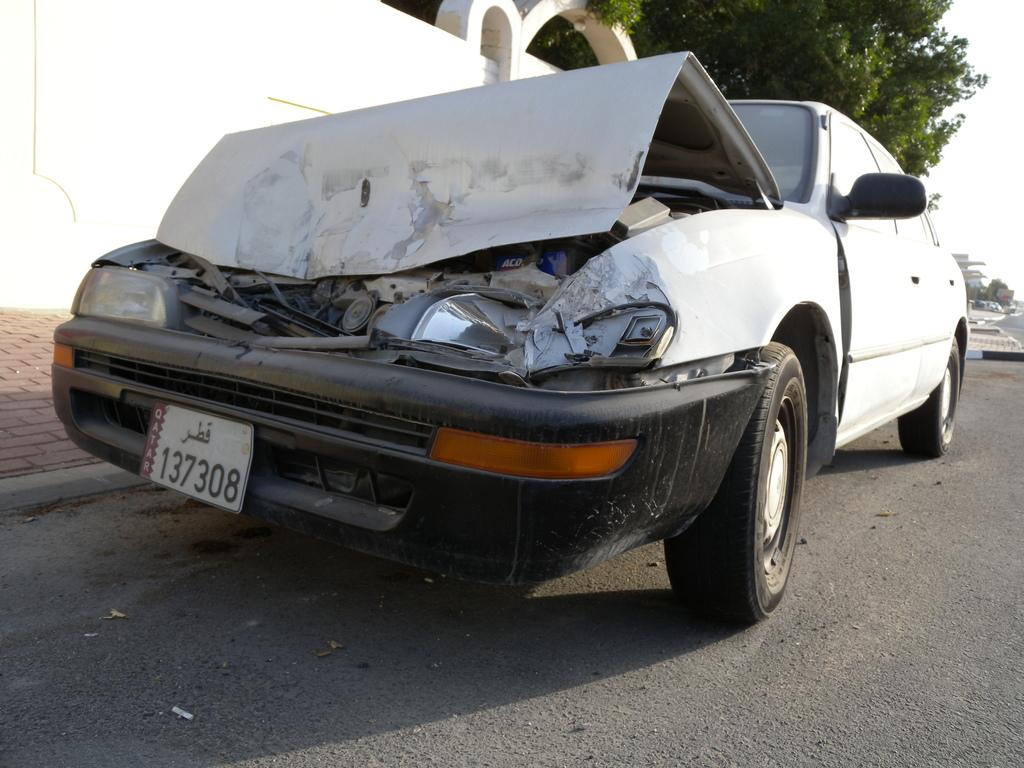Provide a one-sentence caption for the provided image. a license plate with 137308 on the front. 